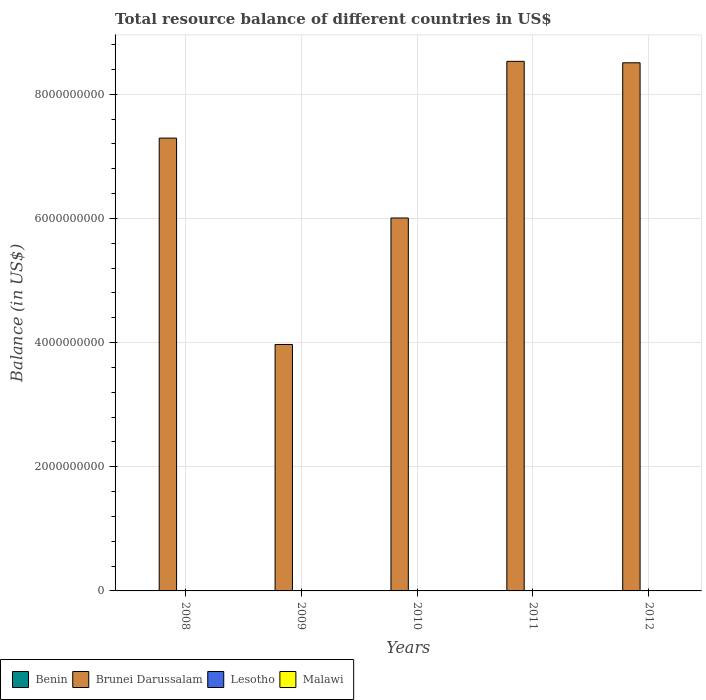How many bars are there on the 2nd tick from the right?
Offer a terse response. 1. Across all years, what is the maximum total resource balance in Brunei Darussalam?
Your answer should be compact. 8.53e+09. What is the difference between the total resource balance in Brunei Darussalam in 2009 and that in 2012?
Keep it short and to the point. -4.54e+09. What is the difference between the total resource balance in Brunei Darussalam in 2008 and the total resource balance in Benin in 2012?
Offer a very short reply. 7.30e+09. What is the ratio of the total resource balance in Brunei Darussalam in 2009 to that in 2010?
Your answer should be very brief. 0.66. Is the total resource balance in Brunei Darussalam in 2009 less than that in 2011?
Offer a terse response. Yes. What is the difference between the highest and the second highest total resource balance in Brunei Darussalam?
Provide a short and direct response. 2.32e+07. What is the difference between the highest and the lowest total resource balance in Brunei Darussalam?
Your response must be concise. 4.56e+09. In how many years, is the total resource balance in Benin greater than the average total resource balance in Benin taken over all years?
Your response must be concise. 0. How many bars are there?
Offer a terse response. 5. Are all the bars in the graph horizontal?
Your answer should be compact. No. Are the values on the major ticks of Y-axis written in scientific E-notation?
Provide a short and direct response. No. Where does the legend appear in the graph?
Provide a succinct answer. Bottom left. How are the legend labels stacked?
Your answer should be very brief. Horizontal. What is the title of the graph?
Offer a very short reply. Total resource balance of different countries in US$. What is the label or title of the Y-axis?
Provide a succinct answer. Balance (in US$). What is the Balance (in US$) of Benin in 2008?
Your answer should be very brief. 0. What is the Balance (in US$) of Brunei Darussalam in 2008?
Your response must be concise. 7.30e+09. What is the Balance (in US$) in Malawi in 2008?
Your answer should be compact. 0. What is the Balance (in US$) in Brunei Darussalam in 2009?
Offer a terse response. 3.97e+09. What is the Balance (in US$) of Malawi in 2009?
Ensure brevity in your answer.  0. What is the Balance (in US$) in Benin in 2010?
Your answer should be very brief. 0. What is the Balance (in US$) in Brunei Darussalam in 2010?
Your answer should be very brief. 6.01e+09. What is the Balance (in US$) of Malawi in 2010?
Provide a short and direct response. 0. What is the Balance (in US$) in Brunei Darussalam in 2011?
Offer a very short reply. 8.53e+09. What is the Balance (in US$) in Lesotho in 2011?
Give a very brief answer. 0. What is the Balance (in US$) in Malawi in 2011?
Your answer should be compact. 0. What is the Balance (in US$) in Brunei Darussalam in 2012?
Give a very brief answer. 8.51e+09. Across all years, what is the maximum Balance (in US$) of Brunei Darussalam?
Make the answer very short. 8.53e+09. Across all years, what is the minimum Balance (in US$) of Brunei Darussalam?
Provide a succinct answer. 3.97e+09. What is the total Balance (in US$) of Benin in the graph?
Your answer should be compact. 0. What is the total Balance (in US$) in Brunei Darussalam in the graph?
Make the answer very short. 3.43e+1. What is the total Balance (in US$) of Malawi in the graph?
Give a very brief answer. 0. What is the difference between the Balance (in US$) in Brunei Darussalam in 2008 and that in 2009?
Give a very brief answer. 3.32e+09. What is the difference between the Balance (in US$) of Brunei Darussalam in 2008 and that in 2010?
Offer a terse response. 1.29e+09. What is the difference between the Balance (in US$) of Brunei Darussalam in 2008 and that in 2011?
Your answer should be very brief. -1.24e+09. What is the difference between the Balance (in US$) in Brunei Darussalam in 2008 and that in 2012?
Offer a terse response. -1.21e+09. What is the difference between the Balance (in US$) of Brunei Darussalam in 2009 and that in 2010?
Keep it short and to the point. -2.04e+09. What is the difference between the Balance (in US$) of Brunei Darussalam in 2009 and that in 2011?
Keep it short and to the point. -4.56e+09. What is the difference between the Balance (in US$) of Brunei Darussalam in 2009 and that in 2012?
Ensure brevity in your answer.  -4.54e+09. What is the difference between the Balance (in US$) in Brunei Darussalam in 2010 and that in 2011?
Offer a terse response. -2.52e+09. What is the difference between the Balance (in US$) in Brunei Darussalam in 2010 and that in 2012?
Your response must be concise. -2.50e+09. What is the difference between the Balance (in US$) in Brunei Darussalam in 2011 and that in 2012?
Give a very brief answer. 2.32e+07. What is the average Balance (in US$) of Brunei Darussalam per year?
Offer a terse response. 6.86e+09. What is the ratio of the Balance (in US$) of Brunei Darussalam in 2008 to that in 2009?
Your answer should be compact. 1.84. What is the ratio of the Balance (in US$) in Brunei Darussalam in 2008 to that in 2010?
Give a very brief answer. 1.21. What is the ratio of the Balance (in US$) of Brunei Darussalam in 2008 to that in 2011?
Your response must be concise. 0.86. What is the ratio of the Balance (in US$) in Brunei Darussalam in 2008 to that in 2012?
Give a very brief answer. 0.86. What is the ratio of the Balance (in US$) of Brunei Darussalam in 2009 to that in 2010?
Offer a terse response. 0.66. What is the ratio of the Balance (in US$) in Brunei Darussalam in 2009 to that in 2011?
Your response must be concise. 0.47. What is the ratio of the Balance (in US$) in Brunei Darussalam in 2009 to that in 2012?
Offer a terse response. 0.47. What is the ratio of the Balance (in US$) of Brunei Darussalam in 2010 to that in 2011?
Your response must be concise. 0.7. What is the ratio of the Balance (in US$) of Brunei Darussalam in 2010 to that in 2012?
Your response must be concise. 0.71. What is the ratio of the Balance (in US$) in Brunei Darussalam in 2011 to that in 2012?
Keep it short and to the point. 1. What is the difference between the highest and the second highest Balance (in US$) of Brunei Darussalam?
Keep it short and to the point. 2.32e+07. What is the difference between the highest and the lowest Balance (in US$) in Brunei Darussalam?
Your answer should be compact. 4.56e+09. 